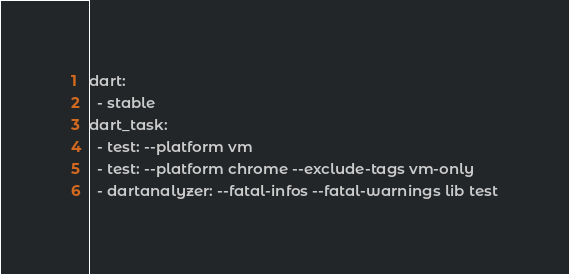Convert code to text. <code><loc_0><loc_0><loc_500><loc_500><_YAML_>dart:
  - stable
dart_task:
  - test: --platform vm
  - test: --platform chrome --exclude-tags vm-only
  - dartanalyzer: --fatal-infos --fatal-warnings lib test
</code> 